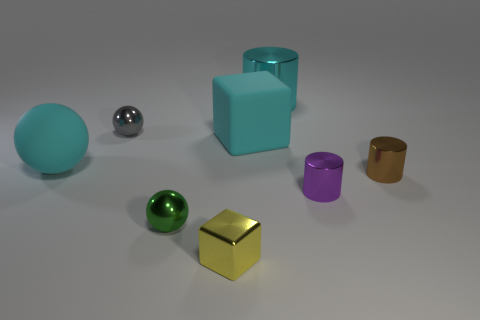There is a gray metal thing that is the same shape as the small green thing; what size is it?
Your answer should be compact. Small. There is a purple object; is it the same shape as the small brown object that is behind the tiny green metallic object?
Give a very brief answer. Yes. What color is the big matte object on the right side of the tiny metallic cube in front of the cyan object to the left of the tiny yellow cube?
Your response must be concise. Cyan. Are there any blocks in front of the brown shiny object?
Give a very brief answer. Yes. What is the size of the rubber sphere that is the same color as the big matte cube?
Provide a succinct answer. Large. Is there a cylinder made of the same material as the purple object?
Offer a terse response. Yes. The small metallic cube has what color?
Ensure brevity in your answer.  Yellow. Do the metallic object that is right of the purple object and the tiny purple thing have the same shape?
Ensure brevity in your answer.  Yes. What shape is the large cyan matte thing on the right side of the ball that is in front of the cylinder in front of the brown cylinder?
Offer a very short reply. Cube. There is a cube right of the small yellow block; what material is it?
Your answer should be very brief. Rubber. 